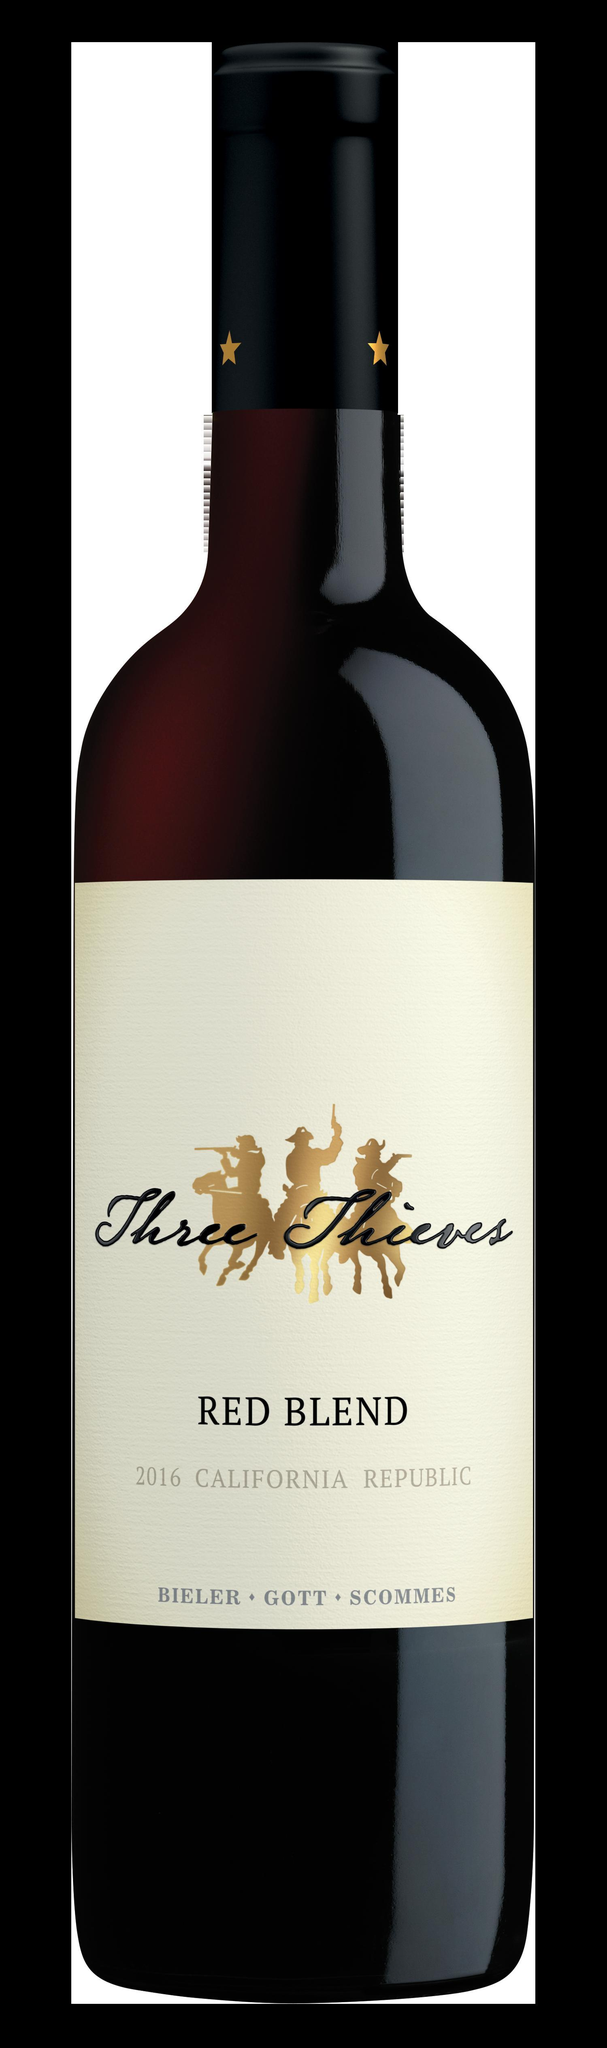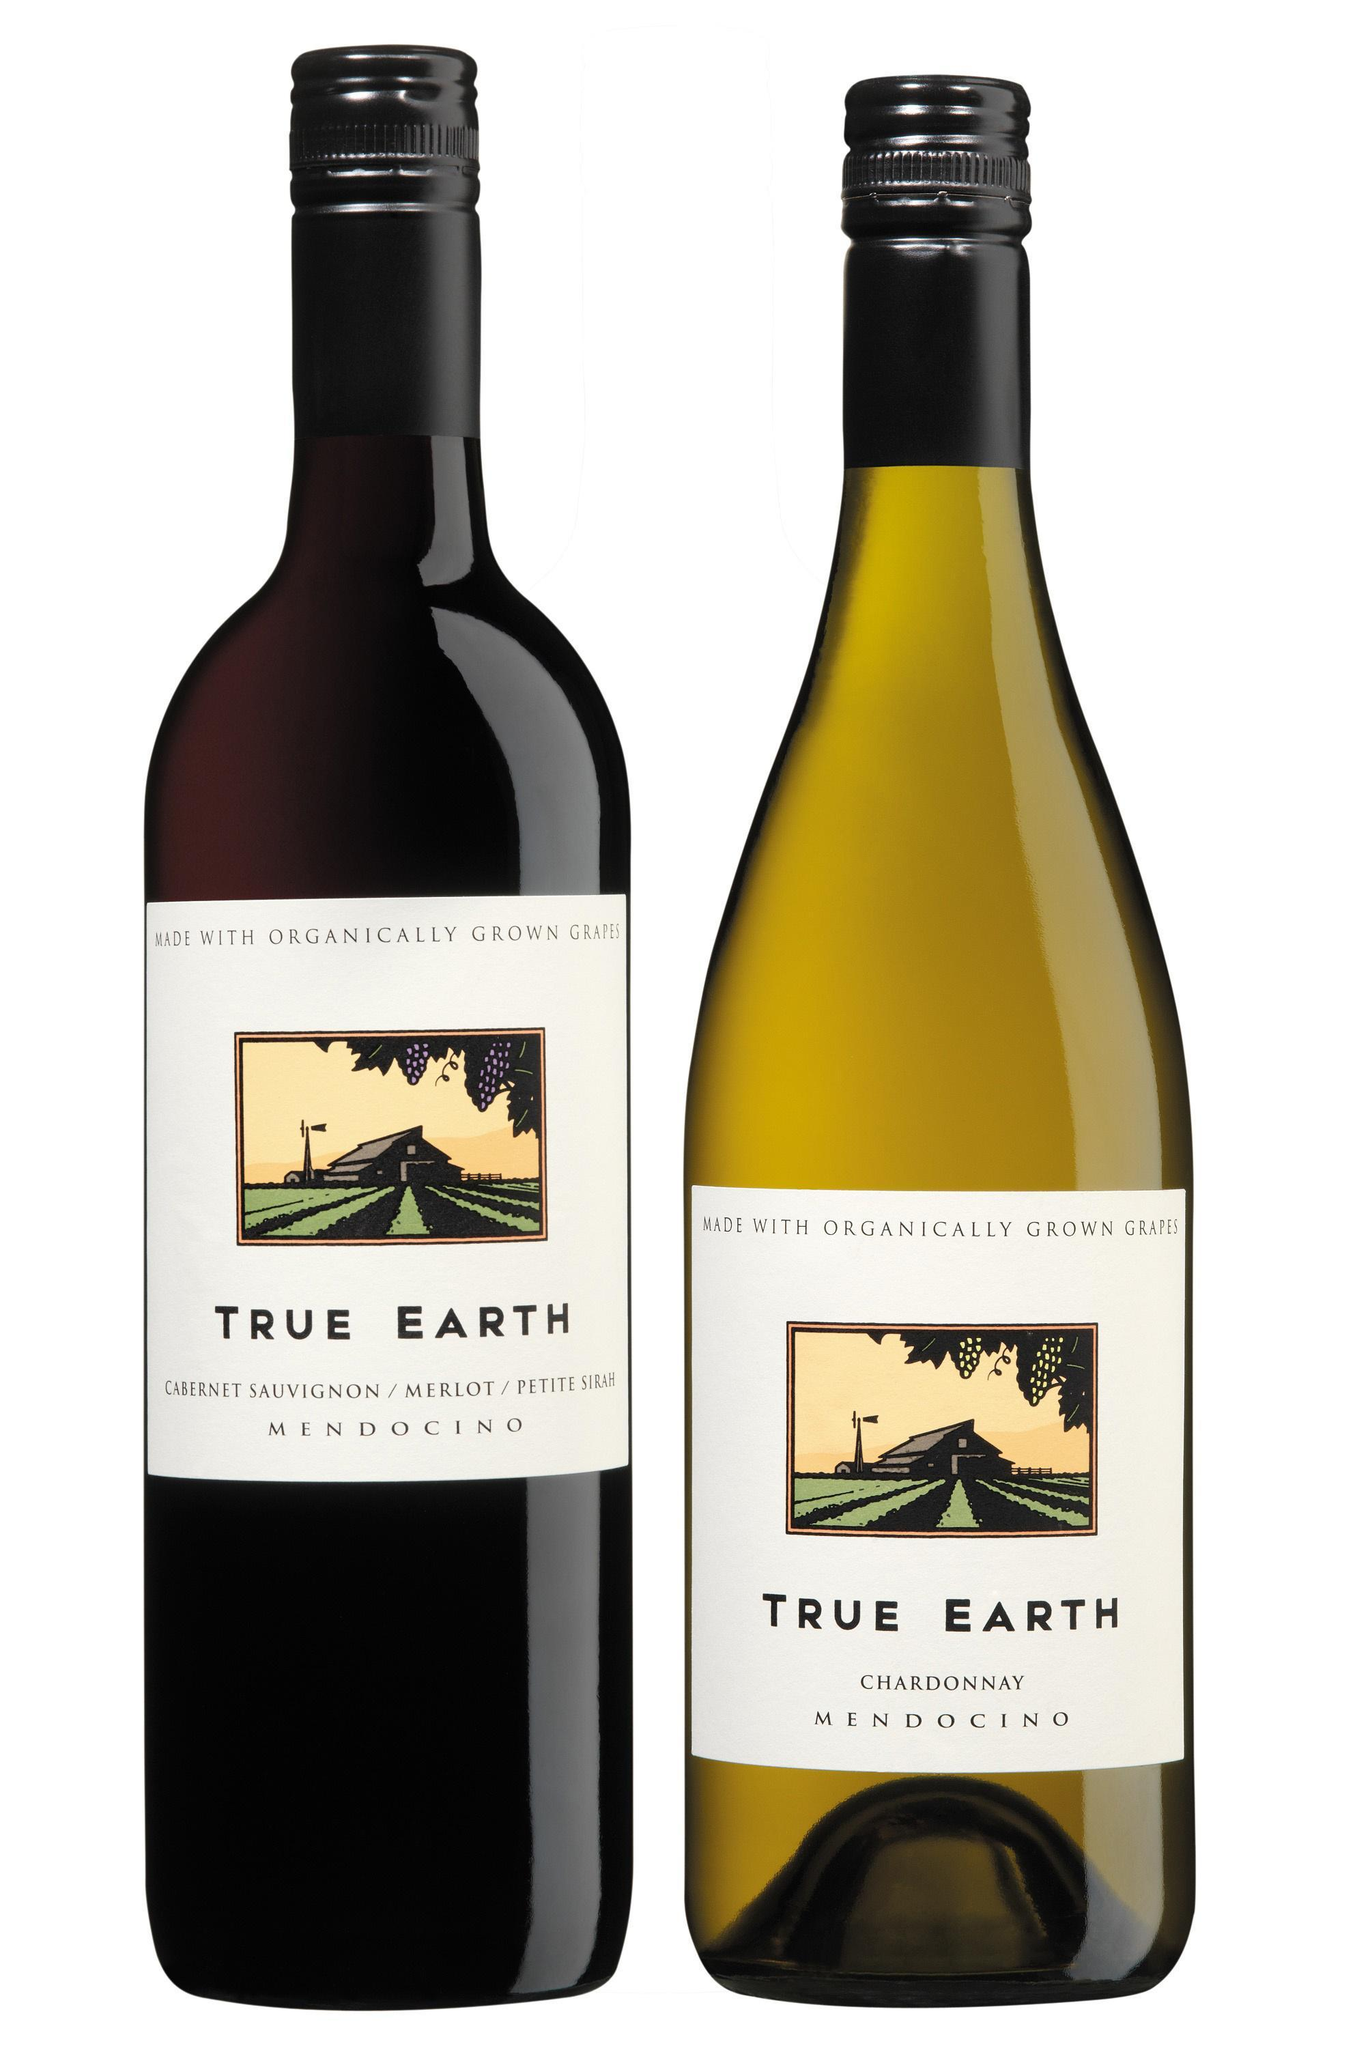The first image is the image on the left, the second image is the image on the right. For the images displayed, is the sentence "The label of the bottle of red wine has the words Three Thieves in gold writing." factually correct? Answer yes or no. No. The first image is the image on the left, the second image is the image on the right. For the images displayed, is the sentence "The combined images include at least two wine bottles with white-background labels." factually correct? Answer yes or no. Yes. 